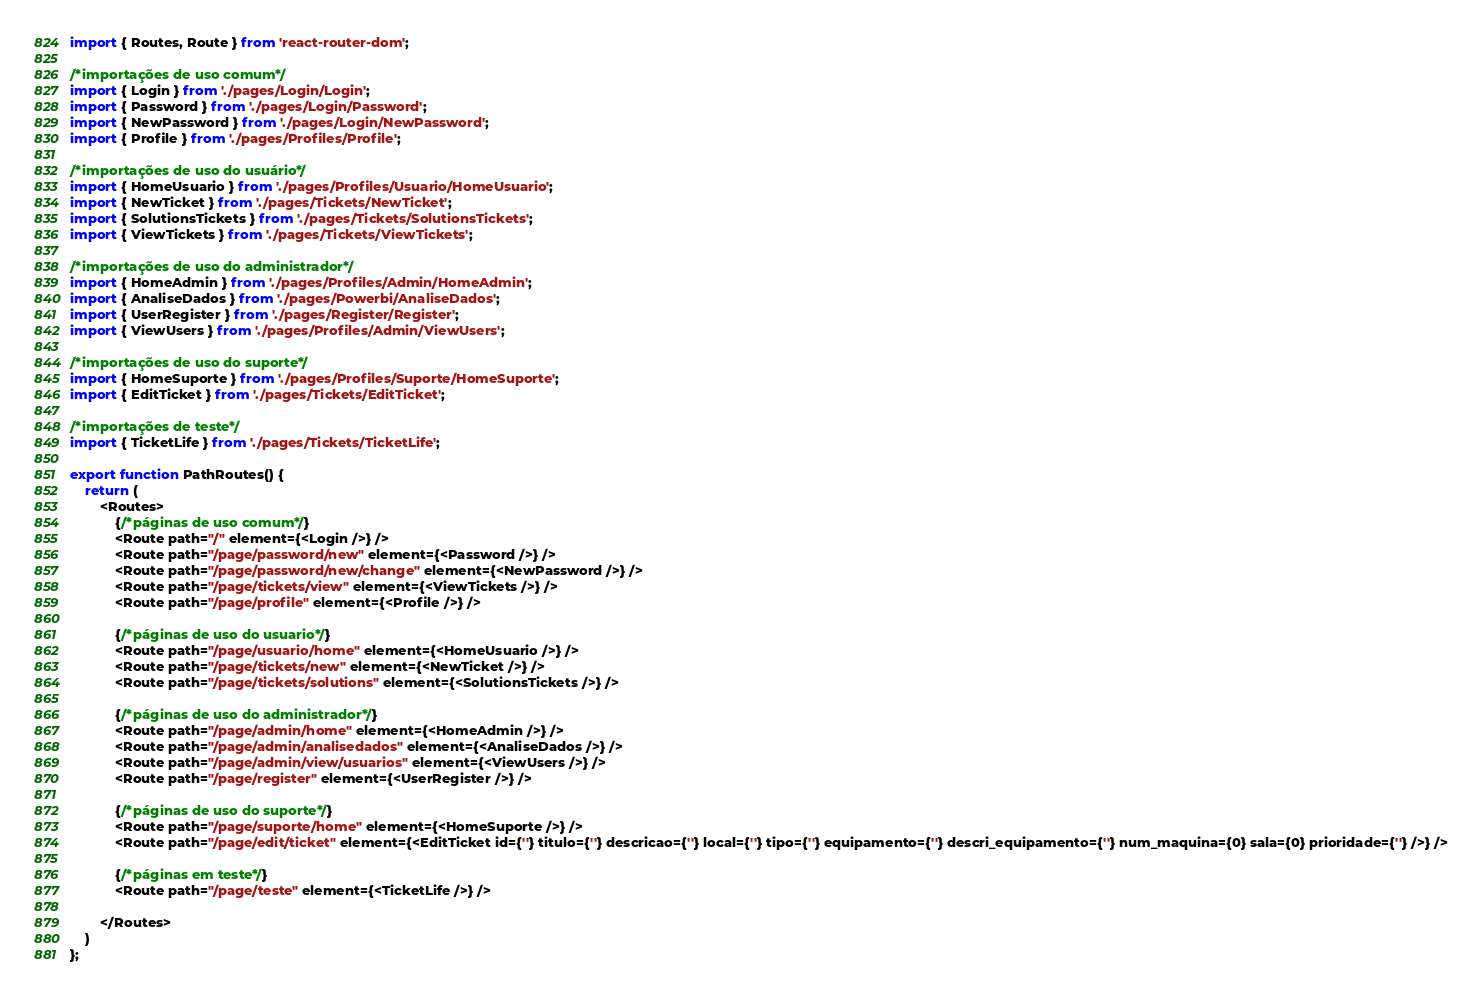<code> <loc_0><loc_0><loc_500><loc_500><_TypeScript_>import { Routes, Route } from 'react-router-dom';

/*importações de uso comum*/
import { Login } from './pages/Login/Login';
import { Password } from './pages/Login/Password';
import { NewPassword } from './pages/Login/NewPassword';
import { Profile } from './pages/Profiles/Profile';

/*importações de uso do usuário*/
import { HomeUsuario } from './pages/Profiles/Usuario/HomeUsuario';
import { NewTicket } from './pages/Tickets/NewTicket';
import { SolutionsTickets } from './pages/Tickets/SolutionsTickets';
import { ViewTickets } from './pages/Tickets/ViewTickets';

/*importações de uso do administrador*/
import { HomeAdmin } from './pages/Profiles/Admin/HomeAdmin';
import { AnaliseDados } from './pages/Powerbi/AnaliseDados';
import { UserRegister } from './pages/Register/Register';
import { ViewUsers } from './pages/Profiles/Admin/ViewUsers';

/*importações de uso do suporte*/
import { HomeSuporte } from './pages/Profiles/Suporte/HomeSuporte';
import { EditTicket } from './pages/Tickets/EditTicket';

/*importações de teste*/
import { TicketLife } from './pages/Tickets/TicketLife';

export function PathRoutes() {
    return (
        <Routes>
            {/*páginas de uso comum*/}
            <Route path="/" element={<Login />} />
            <Route path="/page/password/new" element={<Password />} />
            <Route path="/page/password/new/change" element={<NewPassword />} />
            <Route path="/page/tickets/view" element={<ViewTickets />} />
            <Route path="/page/profile" element={<Profile />} />

            {/*páginas de uso do usuario*/}
            <Route path="/page/usuario/home" element={<HomeUsuario />} />
            <Route path="/page/tickets/new" element={<NewTicket />} />
            <Route path="/page/tickets/solutions" element={<SolutionsTickets />} />

            {/*páginas de uso do administrador*/}
            <Route path="/page/admin/home" element={<HomeAdmin />} />
            <Route path="/page/admin/analisedados" element={<AnaliseDados />} />
            <Route path="/page/admin/view/usuarios" element={<ViewUsers />} />
            <Route path="/page/register" element={<UserRegister />} />

            {/*páginas de uso do suporte*/}
            <Route path="/page/suporte/home" element={<HomeSuporte />} />
            <Route path="/page/edit/ticket" element={<EditTicket id={''} titulo={''} descricao={''} local={''} tipo={''} equipamento={''} descri_equipamento={''} num_maquina={0} sala={0} prioridade={''} />} />

            {/*páginas em teste*/}
            <Route path="/page/teste" element={<TicketLife />} />

        </Routes>
    )
};
</code> 